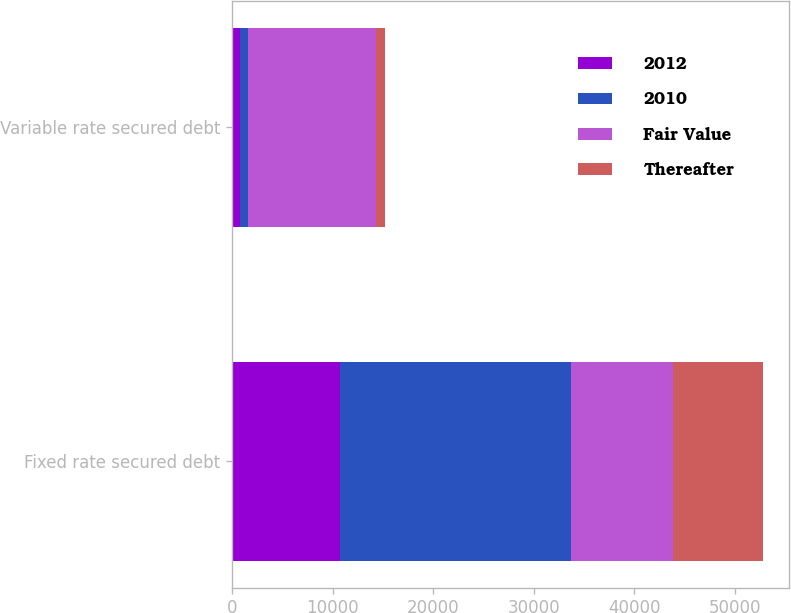Convert chart. <chart><loc_0><loc_0><loc_500><loc_500><stacked_bar_chart><ecel><fcel>Fixed rate secured debt<fcel>Variable rate secured debt<nl><fcel>2012<fcel>10706<fcel>750<nl><fcel>2010<fcel>22975<fcel>785<nl><fcel>Fair Value<fcel>10153<fcel>12748<nl><fcel>Thereafter<fcel>8939<fcel>880<nl></chart> 